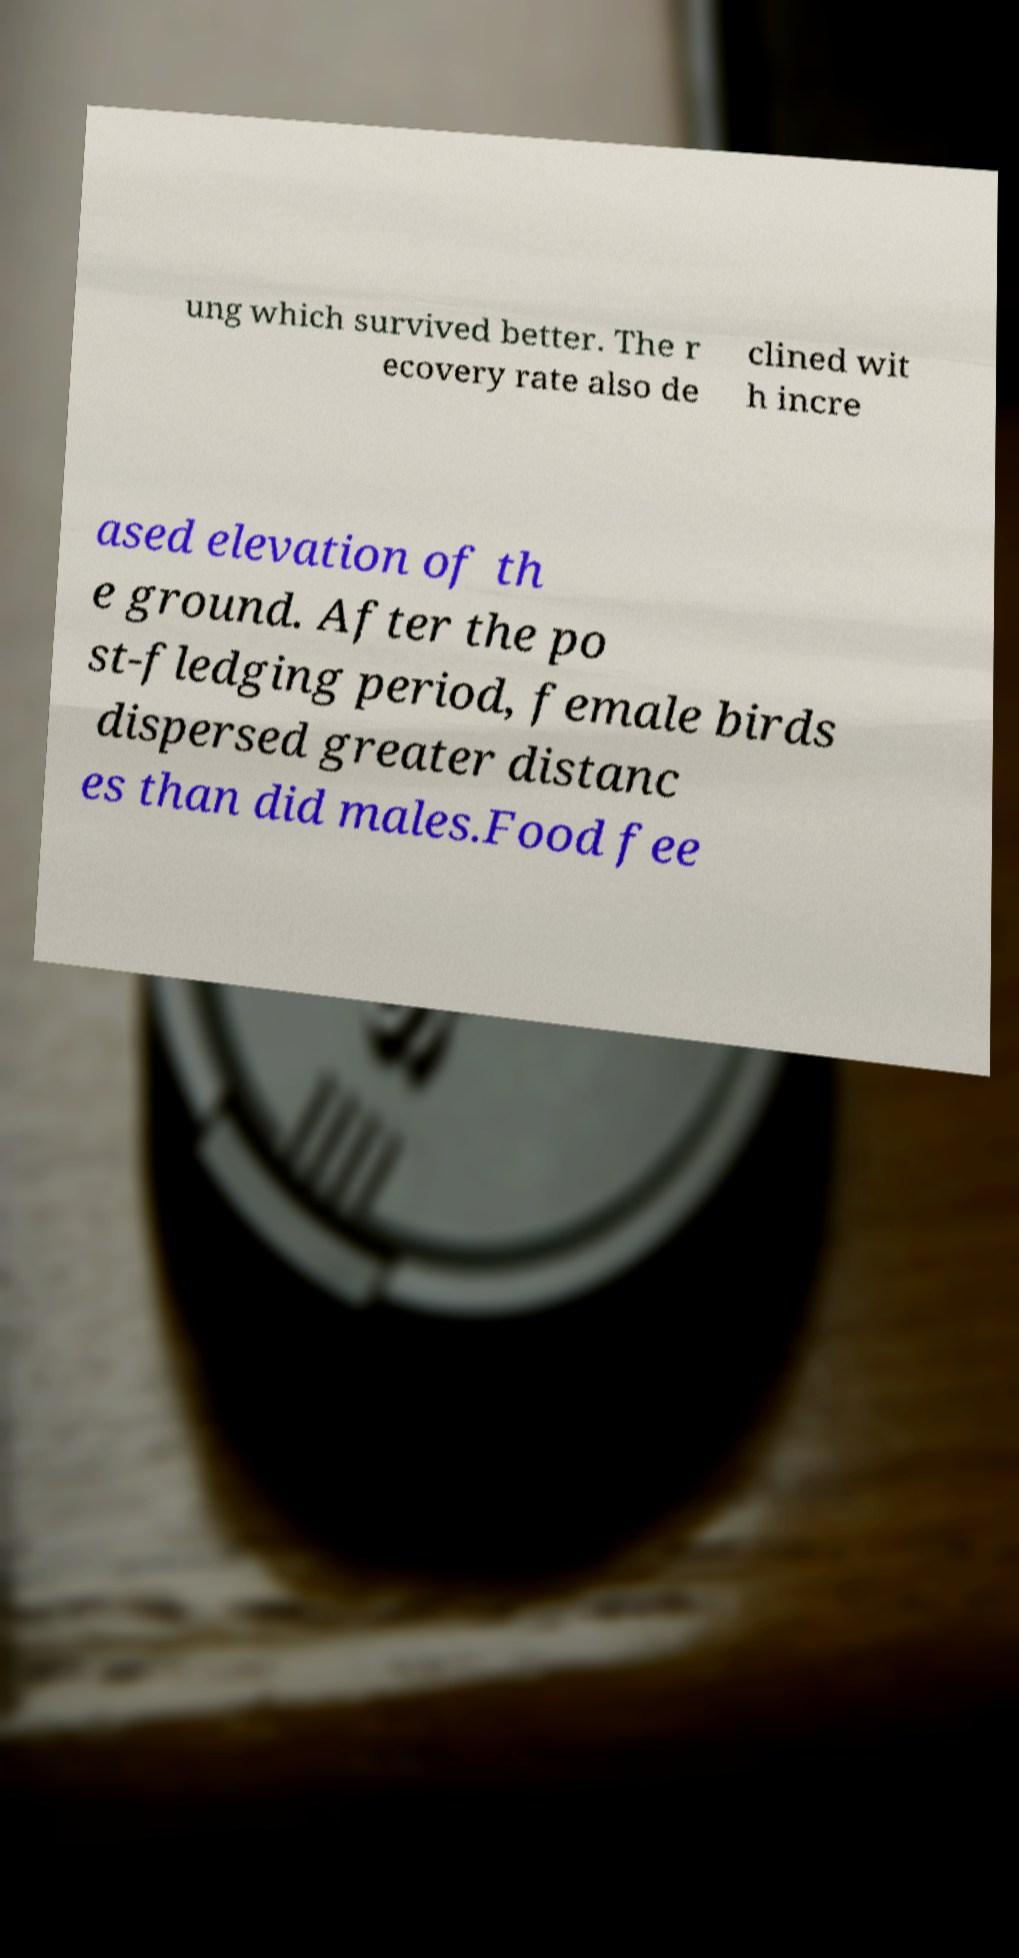Could you extract and type out the text from this image? ung which survived better. The r ecovery rate also de clined wit h incre ased elevation of th e ground. After the po st-fledging period, female birds dispersed greater distanc es than did males.Food fee 